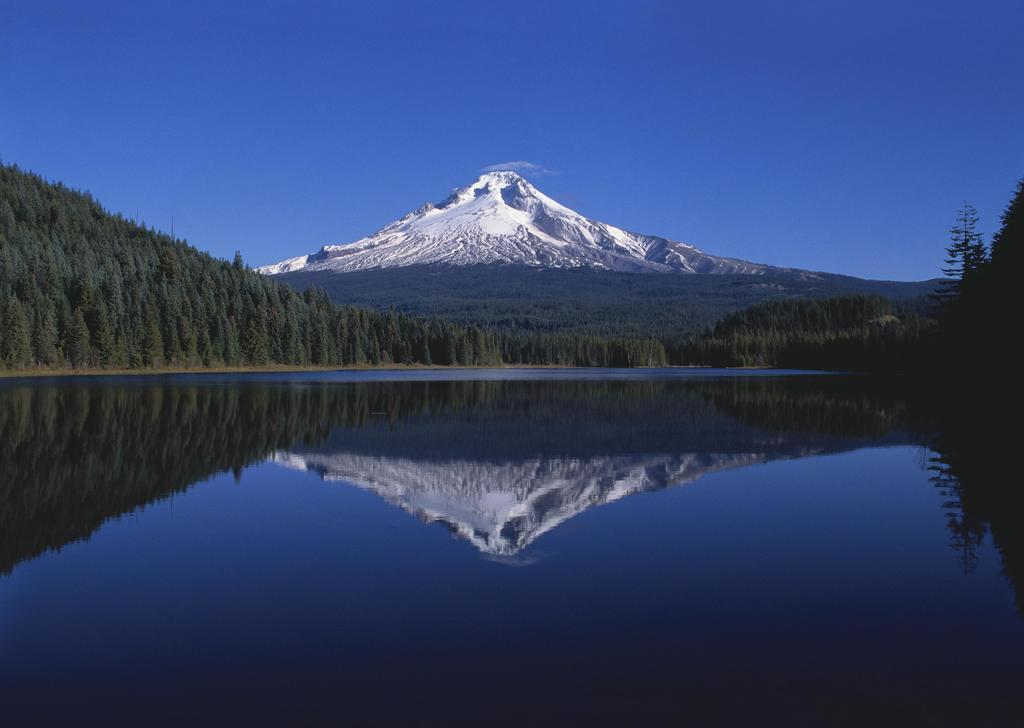What is at the bottom of the image? There is water at the bottom of the image. What can be seen in the water? The water reflects the trees. What type of landscape feature is visible in the image? There is a snow mountain in the image. What is visible in the background of the image? Trees and a snow mountain are visible in the background of the image. What is visible in the sky in the background of the image? Clouds are present in the sky in the background of the image. What type of plastic is used to create the disease in the image? There is no plastic or disease present in the image. What suggestion is being made by the snow mountain in the image? The snow mountain is a landscape feature and does not make any suggestions in the image. 